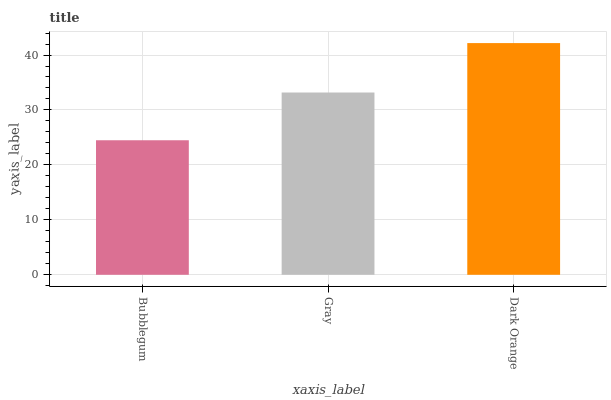Is Bubblegum the minimum?
Answer yes or no. Yes. Is Dark Orange the maximum?
Answer yes or no. Yes. Is Gray the minimum?
Answer yes or no. No. Is Gray the maximum?
Answer yes or no. No. Is Gray greater than Bubblegum?
Answer yes or no. Yes. Is Bubblegum less than Gray?
Answer yes or no. Yes. Is Bubblegum greater than Gray?
Answer yes or no. No. Is Gray less than Bubblegum?
Answer yes or no. No. Is Gray the high median?
Answer yes or no. Yes. Is Gray the low median?
Answer yes or no. Yes. Is Bubblegum the high median?
Answer yes or no. No. Is Dark Orange the low median?
Answer yes or no. No. 